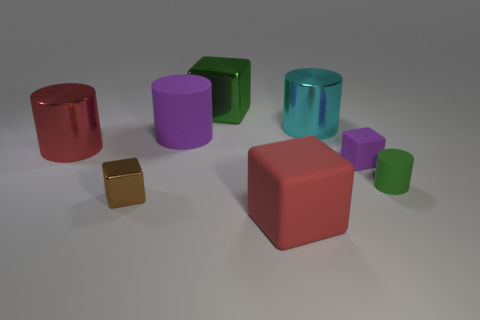What number of tiny matte cylinders are right of the red matte cube?
Offer a very short reply. 1. Is there a cylinder that has the same color as the big matte block?
Your response must be concise. Yes. The cyan thing that is the same size as the red cylinder is what shape?
Provide a succinct answer. Cylinder. What number of red things are large cylinders or metallic cylinders?
Provide a short and direct response. 1. How many red cylinders have the same size as the green cube?
Offer a terse response. 1. What shape is the big metallic object that is the same color as the small cylinder?
Your answer should be very brief. Cube. How many objects are large green cubes or objects that are in front of the purple matte cylinder?
Give a very brief answer. 6. There is a cylinder to the left of the small brown thing; is it the same size as the red block that is on the right side of the tiny brown thing?
Provide a succinct answer. Yes. What number of other metal things are the same shape as the big green thing?
Provide a succinct answer. 1. The cyan object that is the same material as the big red cylinder is what shape?
Keep it short and to the point. Cylinder. 